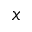Convert formula to latex. <formula><loc_0><loc_0><loc_500><loc_500>x</formula> 